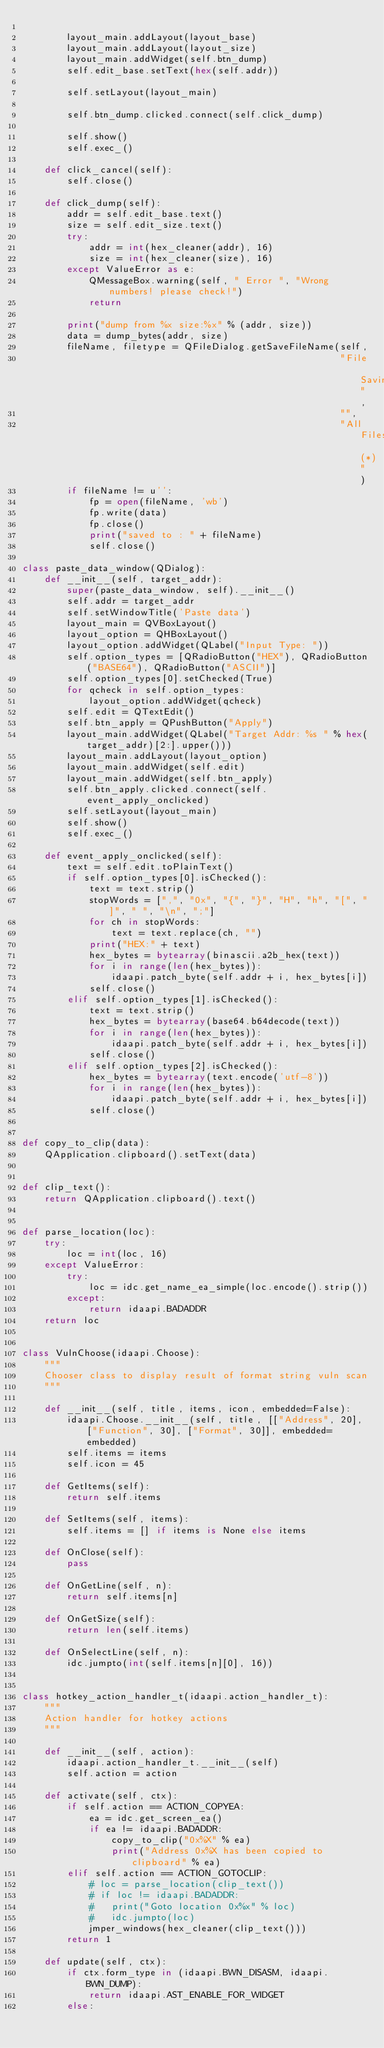<code> <loc_0><loc_0><loc_500><loc_500><_Python_>
        layout_main.addLayout(layout_base)
        layout_main.addLayout(layout_size)
        layout_main.addWidget(self.btn_dump)
        self.edit_base.setText(hex(self.addr))

        self.setLayout(layout_main)

        self.btn_dump.clicked.connect(self.click_dump)

        self.show()
        self.exec_()

    def click_cancel(self):
        self.close()

    def click_dump(self):
        addr = self.edit_base.text()
        size = self.edit_size.text()
        try:
            addr = int(hex_cleaner(addr), 16)
            size = int(hex_cleaner(size), 16)
        except ValueError as e:
            QMessageBox.warning(self, " Error ", "Wrong numbers! please check!")
            return

        print("dump from %x size:%x" % (addr, size))
        data = dump_bytes(addr, size)
        fileName, filetype = QFileDialog.getSaveFileName(self,
                                                         "File Saving",
                                                         "",
                                                         "All Files (*)")
        if fileName != u'':
            fp = open(fileName, 'wb')
            fp.write(data)
            fp.close()
            print("saved to : " + fileName)
            self.close()

class paste_data_window(QDialog):
    def __init__(self, target_addr):
        super(paste_data_window, self).__init__()
        self.addr = target_addr
        self.setWindowTitle('Paste data')
        layout_main = QVBoxLayout()
        layout_option = QHBoxLayout()
        layout_option.addWidget(QLabel("Input Type: "))
        self.option_types = [QRadioButton("HEX"), QRadioButton("BASE64"), QRadioButton("ASCII")]
        self.option_types[0].setChecked(True)
        for qcheck in self.option_types:
            layout_option.addWidget(qcheck)
        self.edit = QTextEdit()
        self.btn_apply = QPushButton("Apply")
        layout_main.addWidget(QLabel("Target Addr: %s " % hex(target_addr)[2:].upper()))
        layout_main.addLayout(layout_option)
        layout_main.addWidget(self.edit)
        layout_main.addWidget(self.btn_apply)
        self.btn_apply.clicked.connect(self.event_apply_onclicked)
        self.setLayout(layout_main)
        self.show()
        self.exec_()

    def event_apply_onclicked(self):
        text = self.edit.toPlainText()
        if self.option_types[0].isChecked():
            text = text.strip()
            stopWords = [",", "0x", "{", "}", "H", "h", "[", "]", " ", "\n", ";"]
            for ch in stopWords:
                text = text.replace(ch, "")
            print("HEX:" + text)
            hex_bytes = bytearray(binascii.a2b_hex(text))
            for i in range(len(hex_bytes)):
                idaapi.patch_byte(self.addr + i, hex_bytes[i])
            self.close()
        elif self.option_types[1].isChecked():
            text = text.strip()
            hex_bytes = bytearray(base64.b64decode(text))
            for i in range(len(hex_bytes)):
                idaapi.patch_byte(self.addr + i, hex_bytes[i])
            self.close()
        elif self.option_types[2].isChecked():
            hex_bytes = bytearray(text.encode('utf-8'))
            for i in range(len(hex_bytes)):
                idaapi.patch_byte(self.addr + i, hex_bytes[i])
            self.close()


def copy_to_clip(data):
    QApplication.clipboard().setText(data)


def clip_text():
    return QApplication.clipboard().text()


def parse_location(loc):
    try:
        loc = int(loc, 16)
    except ValueError:
        try:
            loc = idc.get_name_ea_simple(loc.encode().strip())
        except:
            return idaapi.BADADDR
    return loc


class VulnChoose(idaapi.Choose):
    """
    Chooser class to display result of format string vuln scan
    """

    def __init__(self, title, items, icon, embedded=False):
        idaapi.Choose.__init__(self, title, [["Address", 20], ["Function", 30], ["Format", 30]], embedded=embedded)
        self.items = items
        self.icon = 45

    def GetItems(self):
        return self.items

    def SetItems(self, items):
        self.items = [] if items is None else items

    def OnClose(self):
        pass

    def OnGetLine(self, n):
        return self.items[n]

    def OnGetSize(self):
        return len(self.items)

    def OnSelectLine(self, n):
        idc.jumpto(int(self.items[n][0], 16))


class hotkey_action_handler_t(idaapi.action_handler_t):
    """
    Action handler for hotkey actions
    """

    def __init__(self, action):
        idaapi.action_handler_t.__init__(self)
        self.action = action

    def activate(self, ctx):
        if self.action == ACTION_COPYEA:
            ea = idc.get_screen_ea()
            if ea != idaapi.BADADDR:
                copy_to_clip("0x%X" % ea)
                print("Address 0x%X has been copied to clipboard" % ea)
        elif self.action == ACTION_GOTOCLIP:
            # loc = parse_location(clip_text())
            # if loc != idaapi.BADADDR:
            #   print("Goto location 0x%x" % loc)
            #   idc.jumpto(loc)
            jmper_windows(hex_cleaner(clip_text()))
        return 1

    def update(self, ctx):
        if ctx.form_type in (idaapi.BWN_DISASM, idaapi.BWN_DUMP):
            return idaapi.AST_ENABLE_FOR_WIDGET
        else:</code> 